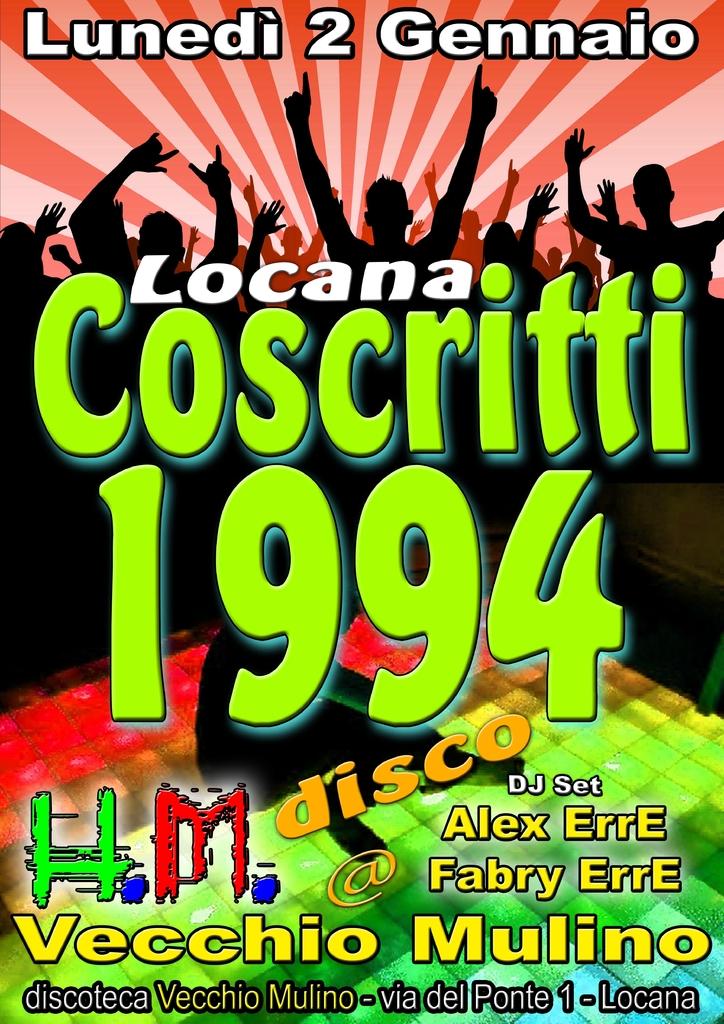What year is on this poster?
Offer a terse response. 1994. Is this a dj set?
Your response must be concise. Yes. 